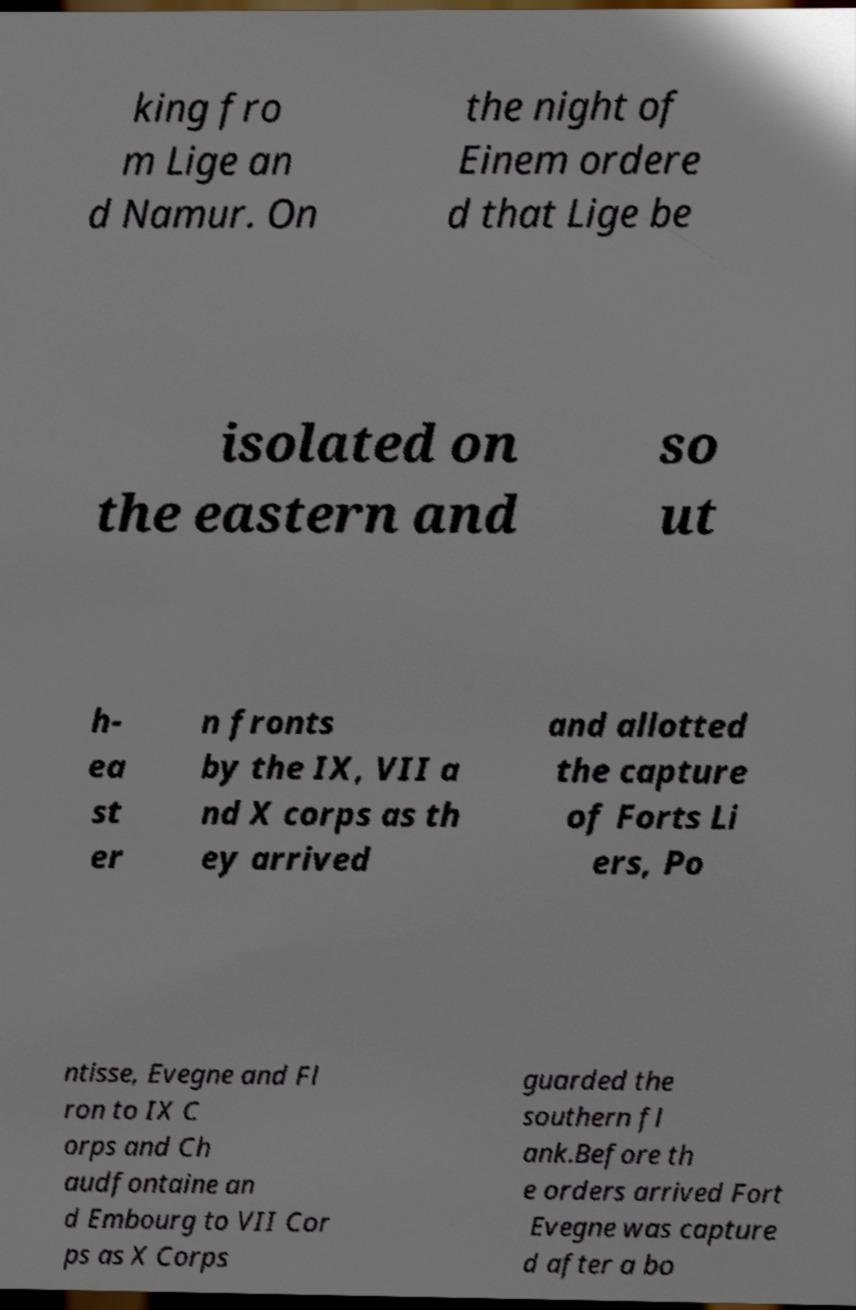What messages or text are displayed in this image? I need them in a readable, typed format. king fro m Lige an d Namur. On the night of Einem ordere d that Lige be isolated on the eastern and so ut h- ea st er n fronts by the IX, VII a nd X corps as th ey arrived and allotted the capture of Forts Li ers, Po ntisse, Evegne and Fl ron to IX C orps and Ch audfontaine an d Embourg to VII Cor ps as X Corps guarded the southern fl ank.Before th e orders arrived Fort Evegne was capture d after a bo 